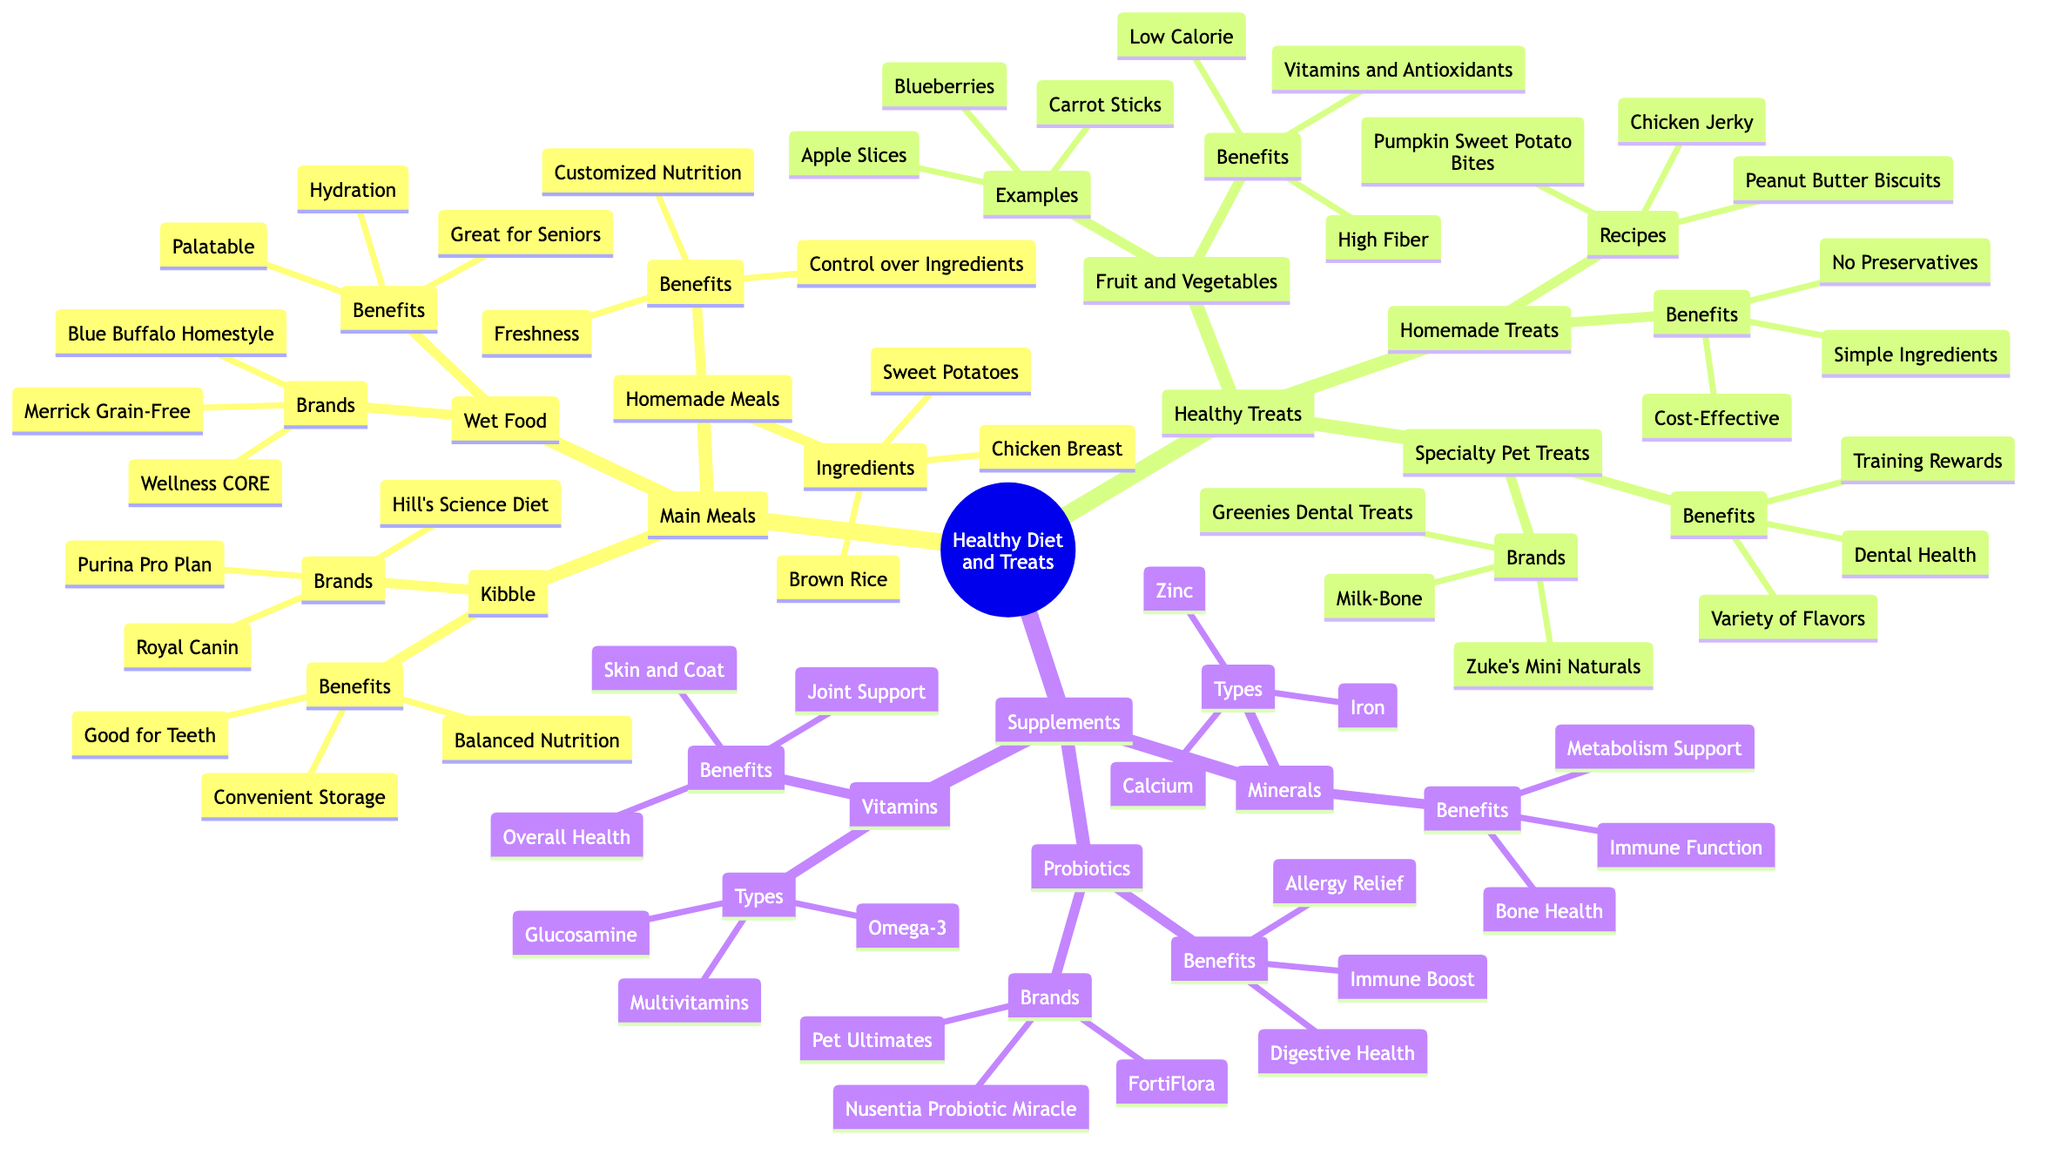What types of food are included in Main Meals? In the diagram, under the Main Meals category, there are three subcategories: Kibble, Wet Food, and Homemade Meals. This indicates that these three types of food are part of the Main Meals section.
Answer: Kibble, Wet Food, Homemade Meals How many examples of Fruit and Vegetables are listed? Under the Fruit and Vegetables category, the diagram lists three examples: Carrot Sticks, Apple Slices, and Blueberries. Thus, the answer is determined by counting these items.
Answer: 3 What is one benefit of Kibble? The Kibble category in the diagram has several listed benefits. One of them is "Balanced Nutrition." The benefits are provided directly in the Kibble section.
Answer: Balanced Nutrition What is the main benefit of Homemade Meals? The "Benefits" node under Homemade Meals lists three items, one of which is "Control over Ingredients." This indicates it is among the primary advantages of choosing homemade meals.
Answer: Control over Ingredients Which category includes Probiotics? The diagram shows that Probiotics are listed under the "Supplements" category. This can be found by tracing the branches from the root through to the Probiotics node.
Answer: Supplements What are the types of Vitamins mentioned? Under the Vitamins category, there are three types listed: Multivitamins, Omega-3, and Glucosamine. By checking the Types node, all three can be identified.
Answer: Multivitamins, Omega-3, Glucosamine What is the main benefit of Specialty Pet Treats? The benefits of Specialty Pet Treats are listed in the diagram, and one of them is "Dental Health." This is one of the key benefits highlighted for that category.
Answer: Dental Health How do fruit and vegetable treats compare to specialty pet treats based on benefits? Fruit and vegetables provide benefits like "Low Calorie," "High Fiber," and "Vitamins and Antioxidants," while specialty pet treats focus on "Training Rewards," "Dental Health," and "Variety of Flavors." This requires comparing the listed benefits of both categories to see their distinctions and commonalities.
Answer: Different benefits Which category has the recipe for Chicken Jerky? In the diagram, Chicken Jerky is mentioned under the Homemade Treats section, specifically under the Recipes node. This indicates that it is directly linked to the Homemade Treats category.
Answer: Homemade Treats 